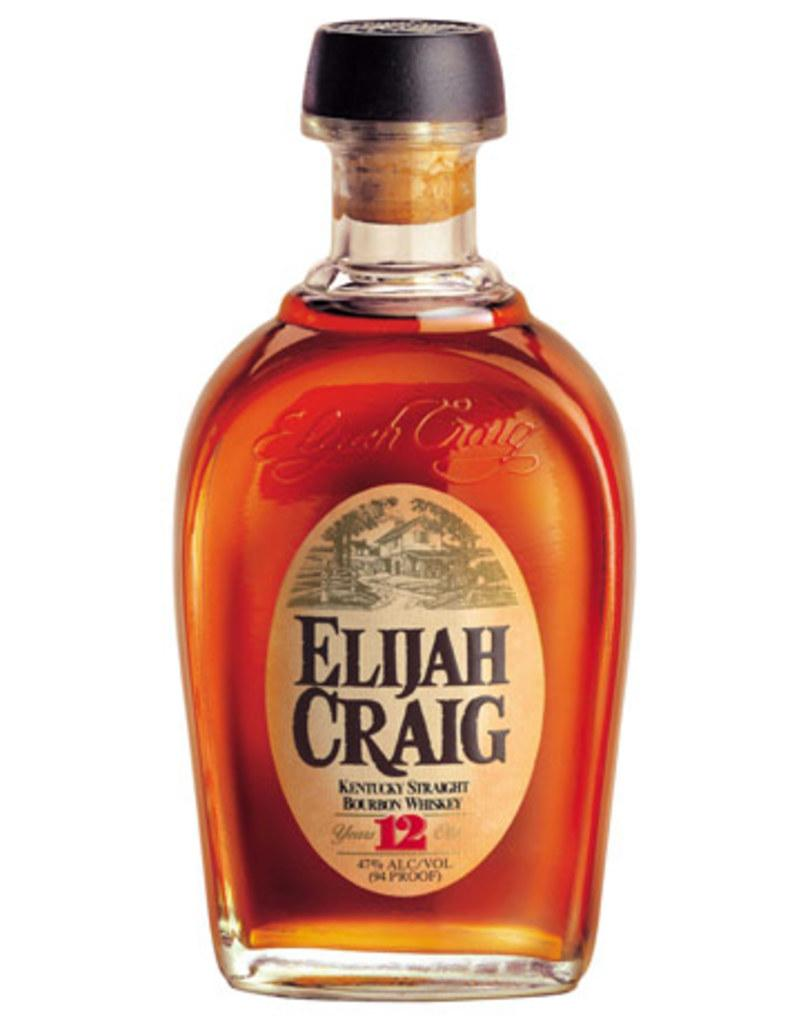<image>
Render a clear and concise summary of the photo. a bottle of whiskey that is called Elijah Craig 